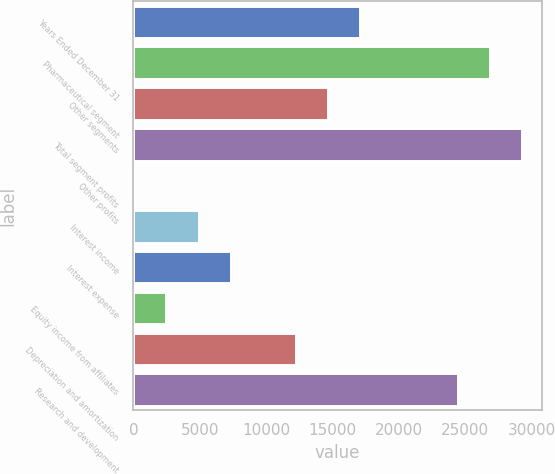Convert chart to OTSL. <chart><loc_0><loc_0><loc_500><loc_500><bar_chart><fcel>Years Ended December 31<fcel>Pharmaceutical segment<fcel>Other segments<fcel>Total segment profits<fcel>Other profits<fcel>Interest income<fcel>Interest expense<fcel>Equity income from affiliates<fcel>Depreciation and amortization<fcel>Research and development<nl><fcel>17101.8<fcel>26859.4<fcel>14662.4<fcel>29298.8<fcel>26<fcel>4904.8<fcel>7344.2<fcel>2465.4<fcel>12223<fcel>24420<nl></chart> 